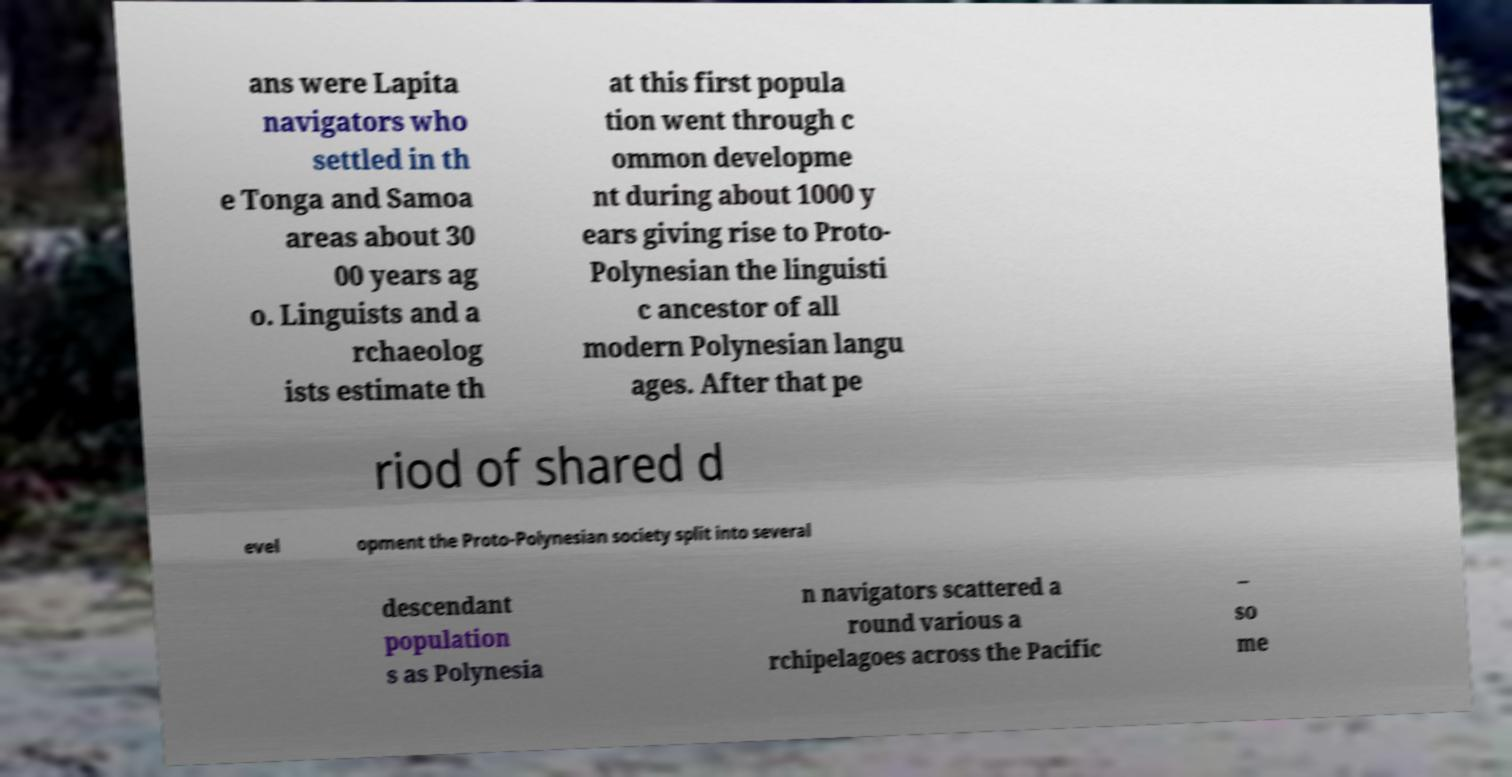Can you read and provide the text displayed in the image?This photo seems to have some interesting text. Can you extract and type it out for me? ans were Lapita navigators who settled in th e Tonga and Samoa areas about 30 00 years ag o. Linguists and a rchaeolog ists estimate th at this first popula tion went through c ommon developme nt during about 1000 y ears giving rise to Proto- Polynesian the linguisti c ancestor of all modern Polynesian langu ages. After that pe riod of shared d evel opment the Proto-Polynesian society split into several descendant population s as Polynesia n navigators scattered a round various a rchipelagoes across the Pacific – so me 